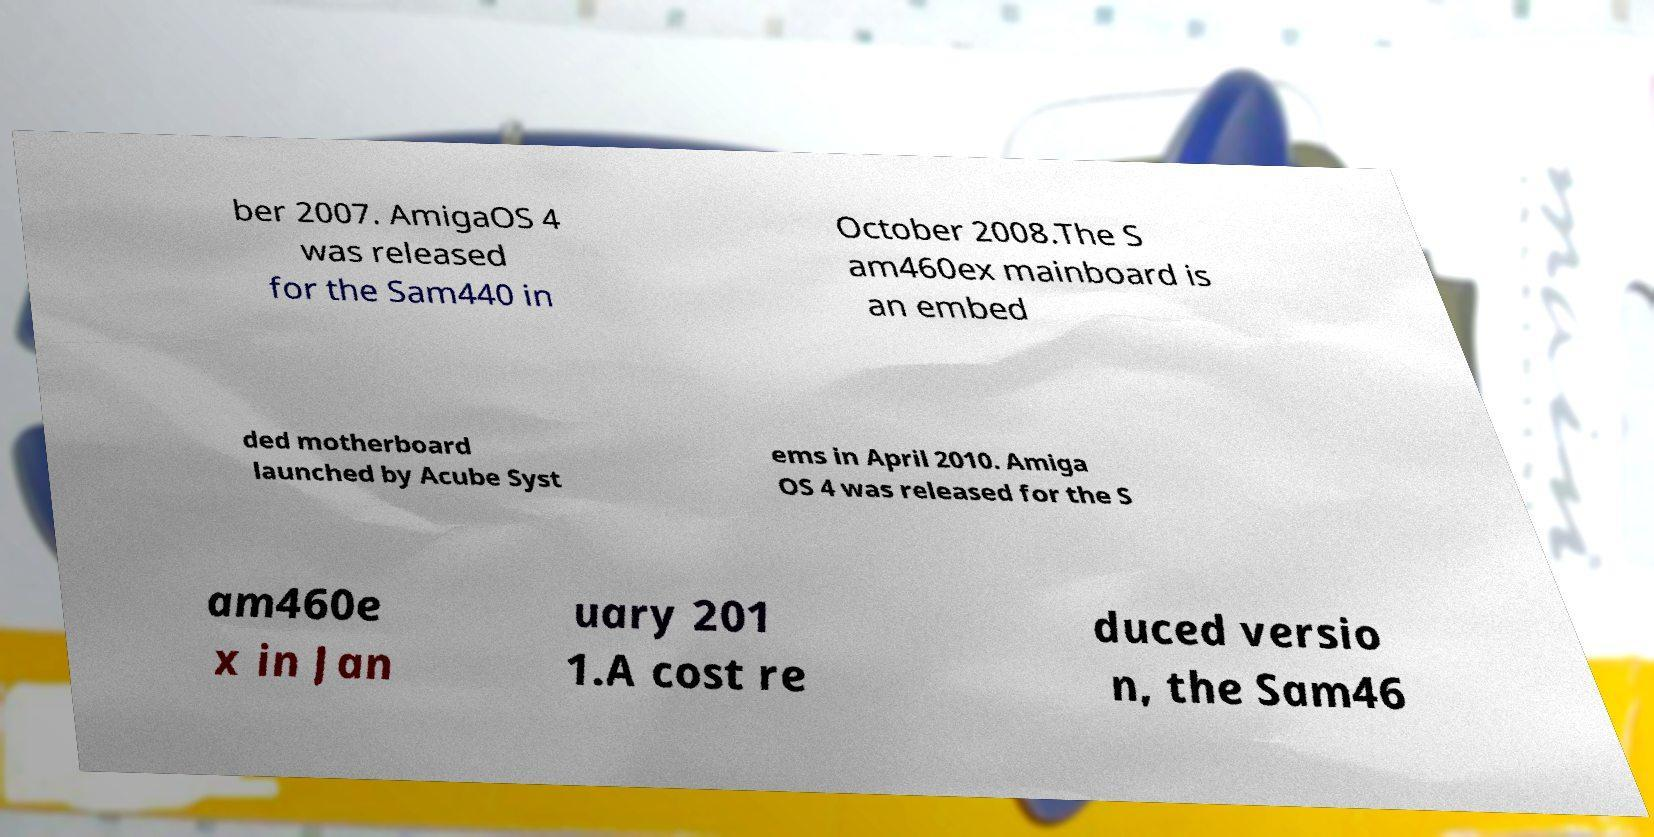Could you assist in decoding the text presented in this image and type it out clearly? ber 2007. AmigaOS 4 was released for the Sam440 in October 2008.The S am460ex mainboard is an embed ded motherboard launched by Acube Syst ems in April 2010. Amiga OS 4 was released for the S am460e x in Jan uary 201 1.A cost re duced versio n, the Sam46 